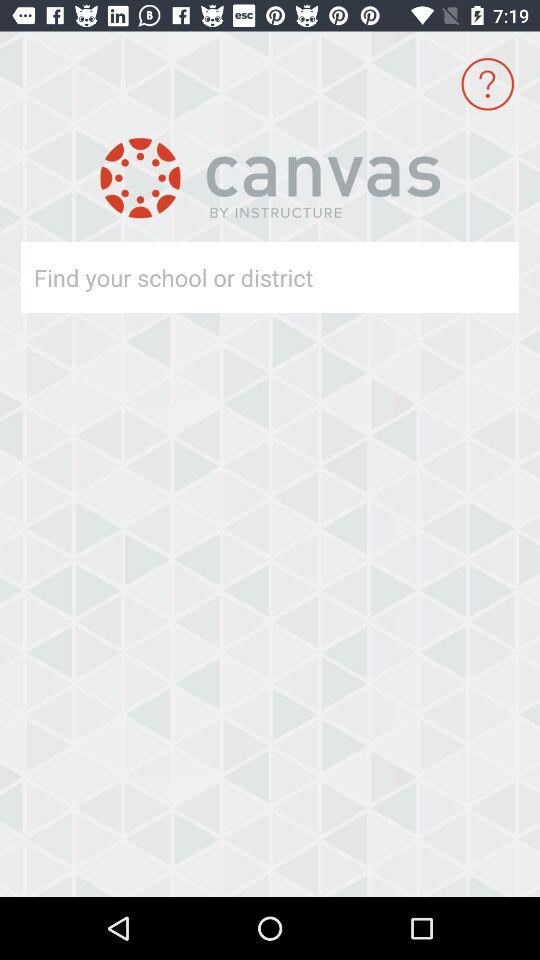What is the application name? The application name is "canvas". 